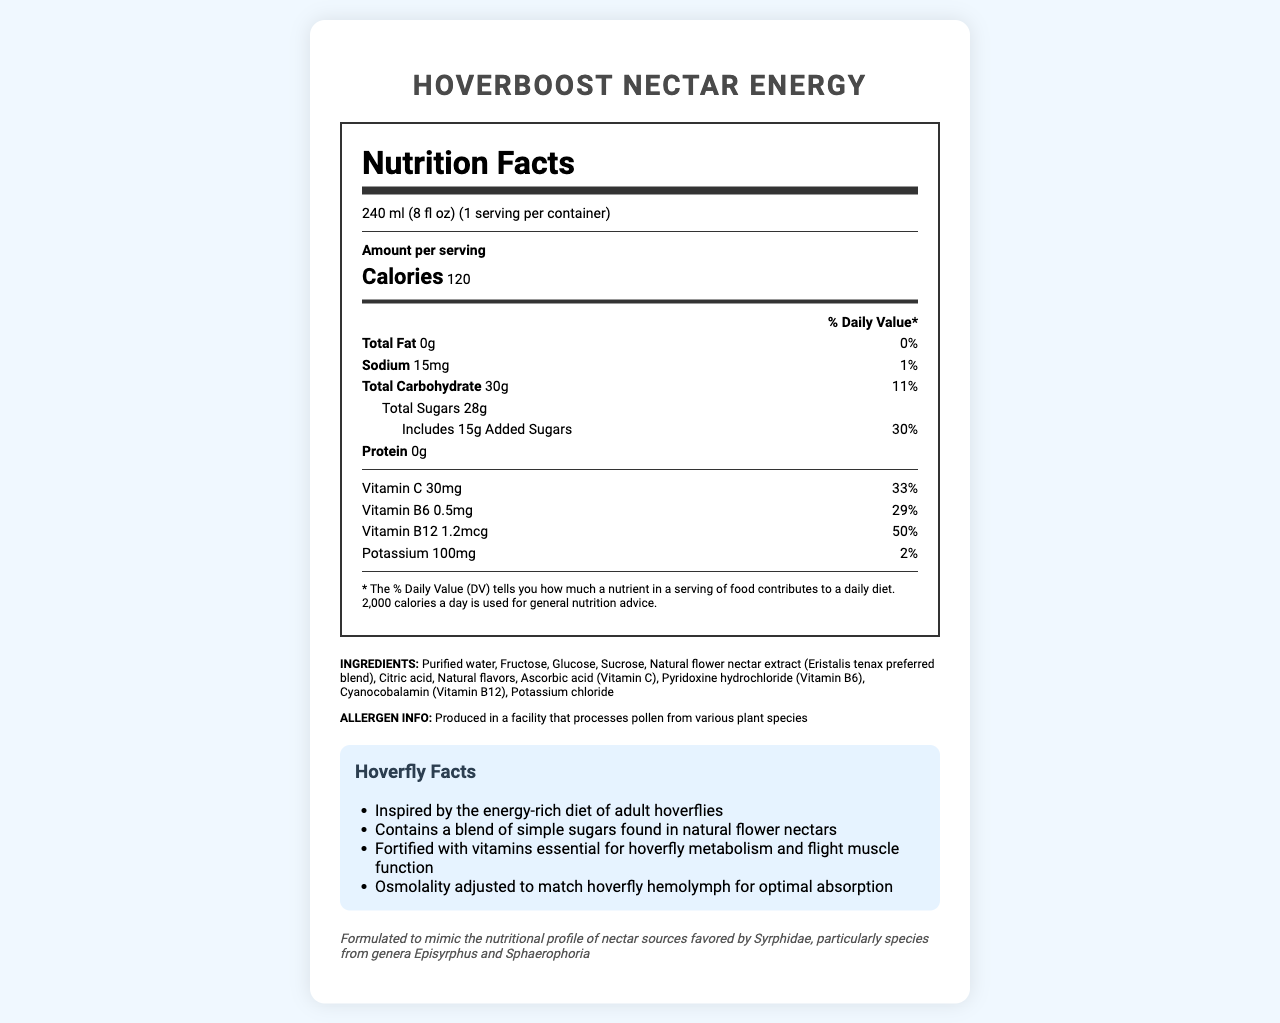what is the serving size? The document clearly states that the serving size is 240 ml (8 fl oz).
Answer: 240 ml (8 fl oz) how many calories are in one serving of HoverBoost Nectar Energy? The Nutrition Facts label indicates that there are 120 calories per serving.
Answer: 120 calories what is the percent daily value of vitamin C? The document lists the percent daily value of vitamin C as 33%.
Answer: 33% list three ingredients found in HoverBoost Nectar Energy The ingredients listed include purified water, fructose, and glucose among others.
Answer: Purified water, Fructose, Glucose what is the amount of total sugars in HoverBoost Nectar Energy? The total amount of sugars is listed as 28g on the Nutrition Facts label.
Answer: 28g how much sodium does one serving contain? A. 0mg B. 15mg C. 30mg D. 45mg The document lists the sodium content as 15mg.
Answer: B which vitamin has the highest percent daily value per serving? A. Vitamin C B. Vitamin B6 C. Vitamin B12 D. Potassium Vitamin B12 has the highest percent daily value at 50%.
Answer: C hoverBoost Nectar Energy includes added sugars. True or False? The Nutrition Facts label shows that it includes 15g of added sugars.
Answer: True summarize the main purpose of HoverBoost Nectar Energy based on the document. The document provides comprehensive nutritional information, ingredients, and highlights its formulation inspired by the dietary needs of hoverflies, aiming to offer a nectar-like energy boost.
Answer: HoverBoost Nectar Energy is a nectar-based energy drink designed to mimic the nutritional profile of nectar sources favored by hoverflies. It contains simple sugars and is fortified with essential vitamins to support energy and metabolism, particularly inspired by the diet of adult hoverflies. what is the osmolality of HoverBoost Nectar Energy? The document mentions that the osmolality is adjusted to match hoverfly hemolymph for optimal absorption, but it does not provide a specific numerical value for the osmolality.
Answer: Cannot be determined 